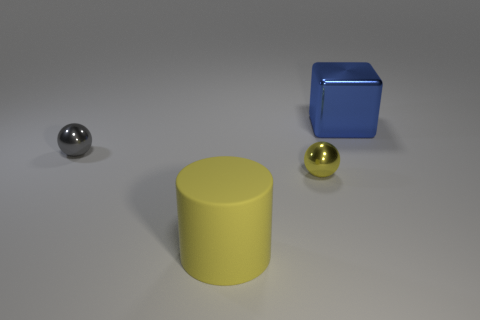Add 3 rubber cylinders. How many objects exist? 7 Subtract all yellow balls. How many balls are left? 1 Subtract all cylinders. How many objects are left? 3 Add 1 small gray things. How many small gray things exist? 2 Subtract 0 cyan cubes. How many objects are left? 4 Subtract 1 blocks. How many blocks are left? 0 Subtract all blue balls. Subtract all purple cylinders. How many balls are left? 2 Subtract all cyan rubber cylinders. Subtract all large yellow matte cylinders. How many objects are left? 3 Add 2 tiny things. How many tiny things are left? 4 